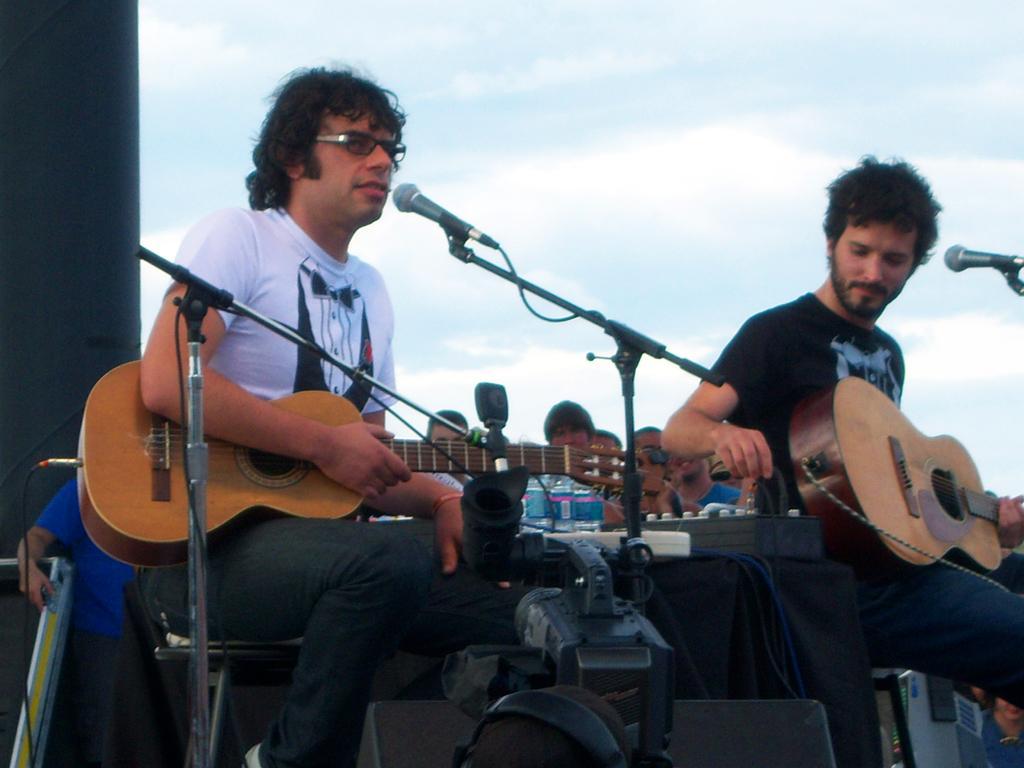How would you summarize this image in a sentence or two? In this image there are two persons who are playing guitar at the foreground of the image there are microphones and at the background of the image there are persons sitting. 